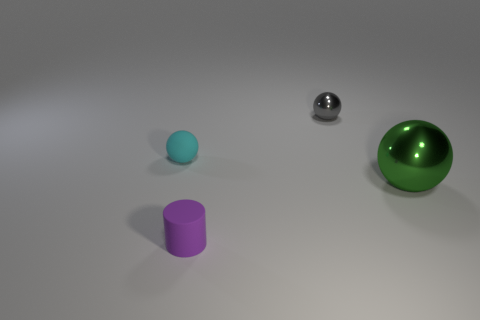Add 3 small purple matte cylinders. How many objects exist? 7 Subtract all cylinders. How many objects are left? 3 Subtract all small objects. Subtract all big green objects. How many objects are left? 0 Add 1 small metallic things. How many small metallic things are left? 2 Add 2 tiny things. How many tiny things exist? 5 Subtract 0 yellow blocks. How many objects are left? 4 